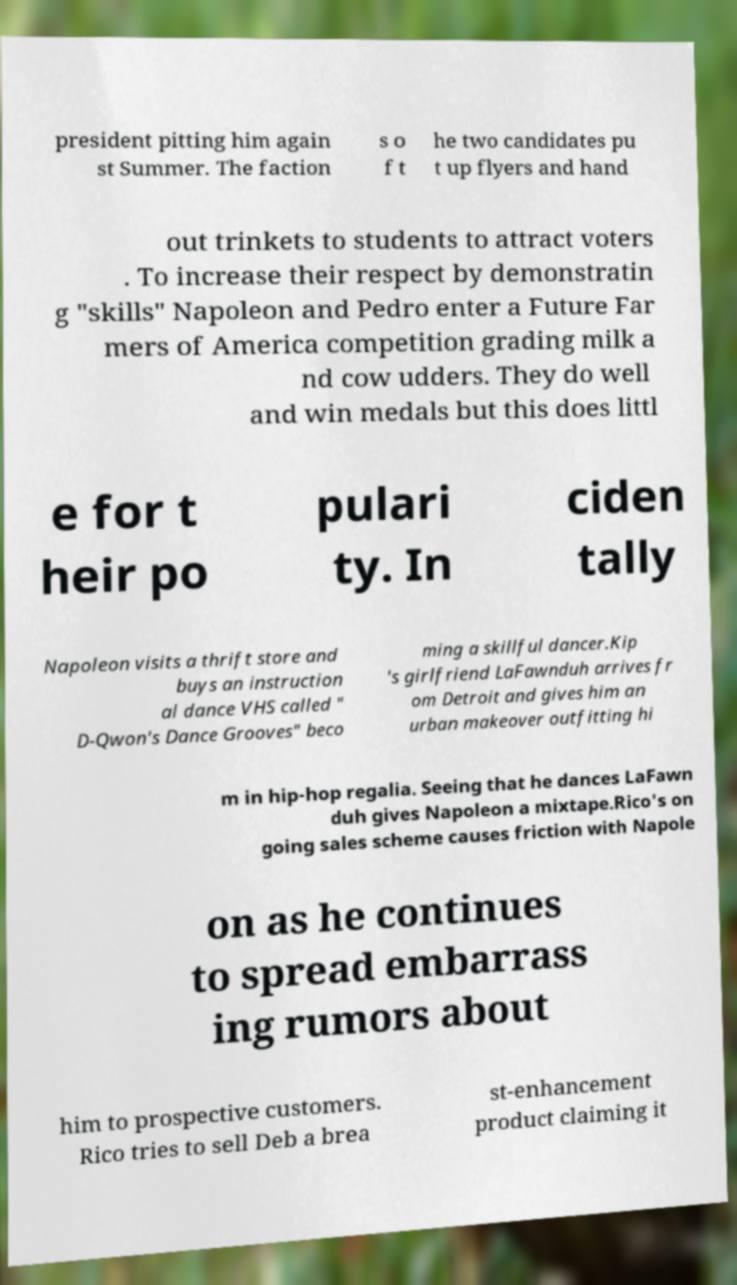Could you extract and type out the text from this image? president pitting him again st Summer. The faction s o f t he two candidates pu t up flyers and hand out trinkets to students to attract voters . To increase their respect by demonstratin g "skills" Napoleon and Pedro enter a Future Far mers of America competition grading milk a nd cow udders. They do well and win medals but this does littl e for t heir po pulari ty. In ciden tally Napoleon visits a thrift store and buys an instruction al dance VHS called " D-Qwon's Dance Grooves" beco ming a skillful dancer.Kip 's girlfriend LaFawnduh arrives fr om Detroit and gives him an urban makeover outfitting hi m in hip-hop regalia. Seeing that he dances LaFawn duh gives Napoleon a mixtape.Rico's on going sales scheme causes friction with Napole on as he continues to spread embarrass ing rumors about him to prospective customers. Rico tries to sell Deb a brea st-enhancement product claiming it 